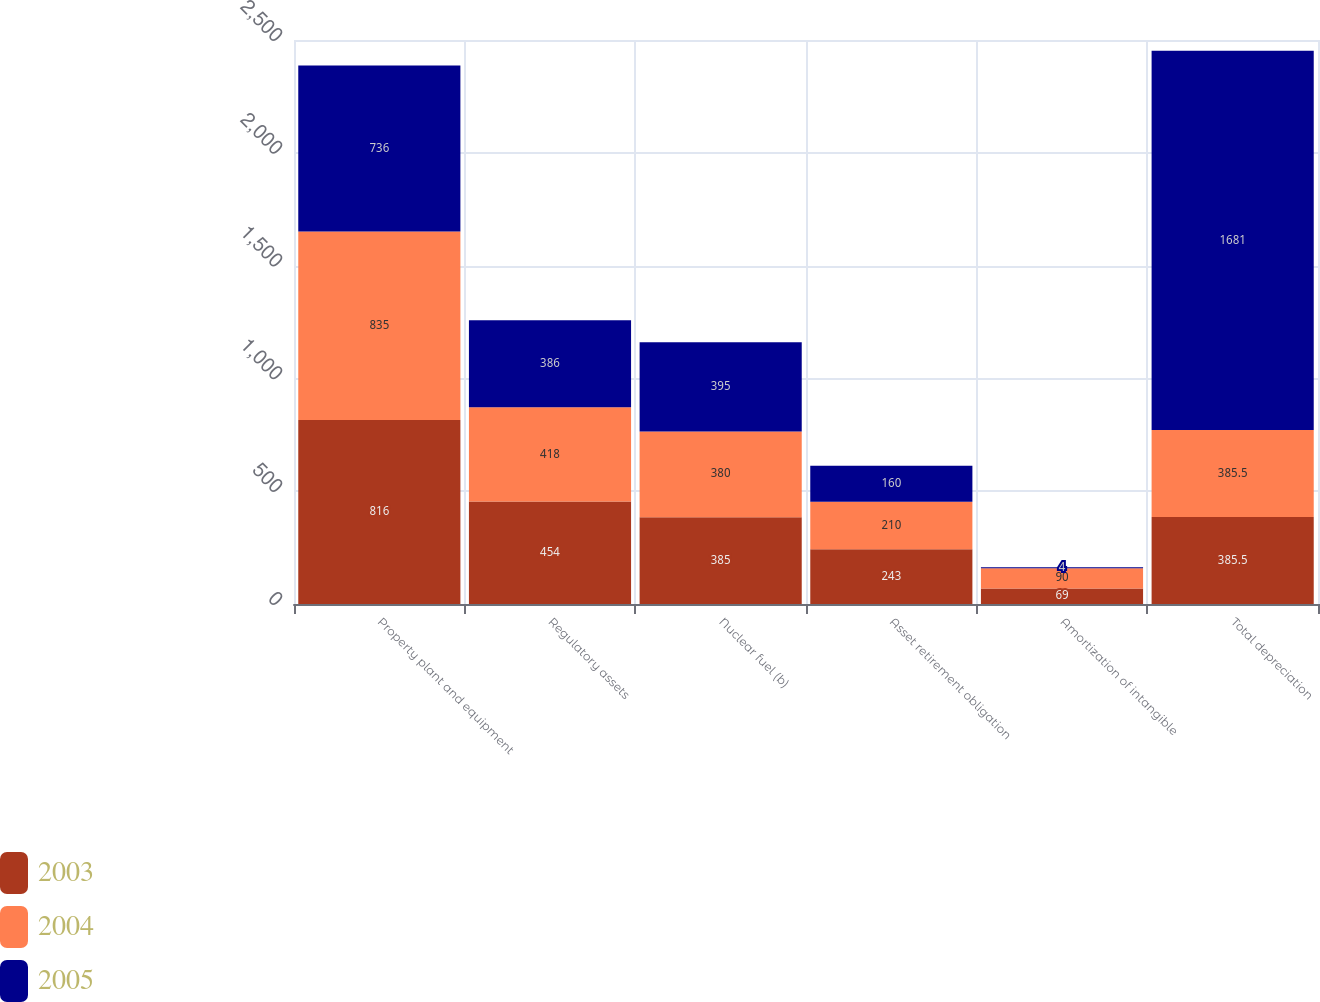<chart> <loc_0><loc_0><loc_500><loc_500><stacked_bar_chart><ecel><fcel>Property plant and equipment<fcel>Regulatory assets<fcel>Nuclear fuel (b)<fcel>Asset retirement obligation<fcel>Amortization of intangible<fcel>Total depreciation<nl><fcel>2003<fcel>816<fcel>454<fcel>385<fcel>243<fcel>69<fcel>385.5<nl><fcel>2004<fcel>835<fcel>418<fcel>380<fcel>210<fcel>90<fcel>385.5<nl><fcel>2005<fcel>736<fcel>386<fcel>395<fcel>160<fcel>4<fcel>1681<nl></chart> 